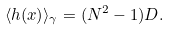Convert formula to latex. <formula><loc_0><loc_0><loc_500><loc_500>\langle h ( x ) \rangle _ { \gamma } = ( N ^ { 2 } - 1 ) D .</formula> 